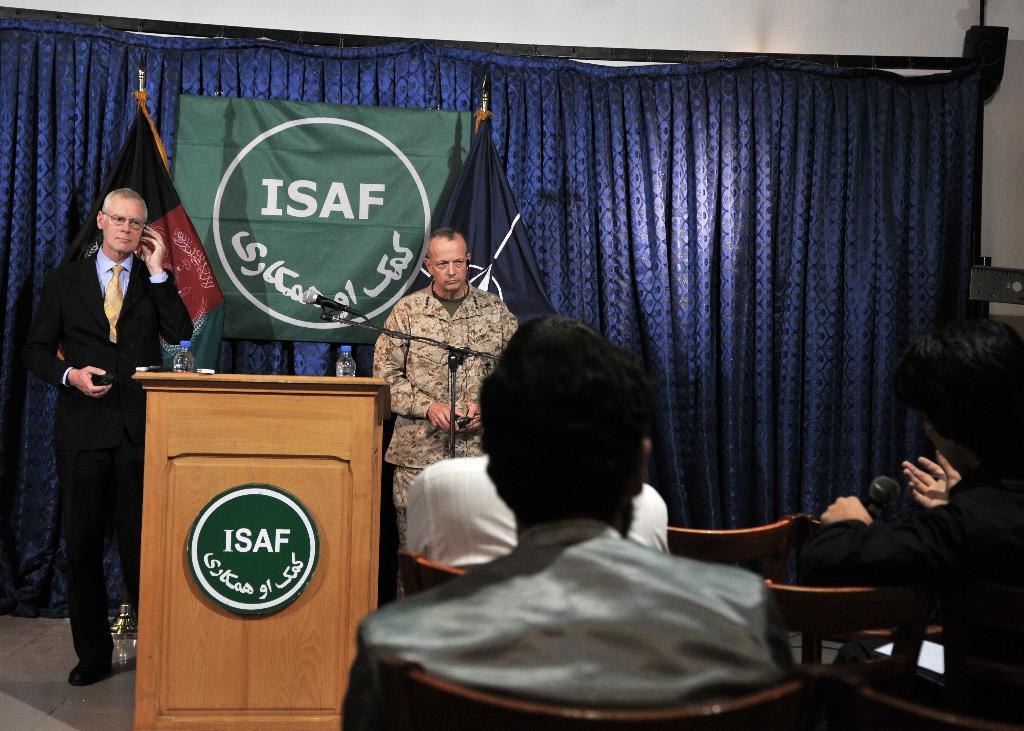<image>
Share a concise interpretation of the image provided. Two men on stage with a green flag saying ISAF 